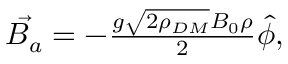<formula> <loc_0><loc_0><loc_500><loc_500>\begin{array} { r } { \vec { B _ { a } } = - \frac { g \sqrt { 2 \rho _ { D M } } B _ { 0 } \rho } { 2 } \hat { \phi } , } \end{array}</formula> 